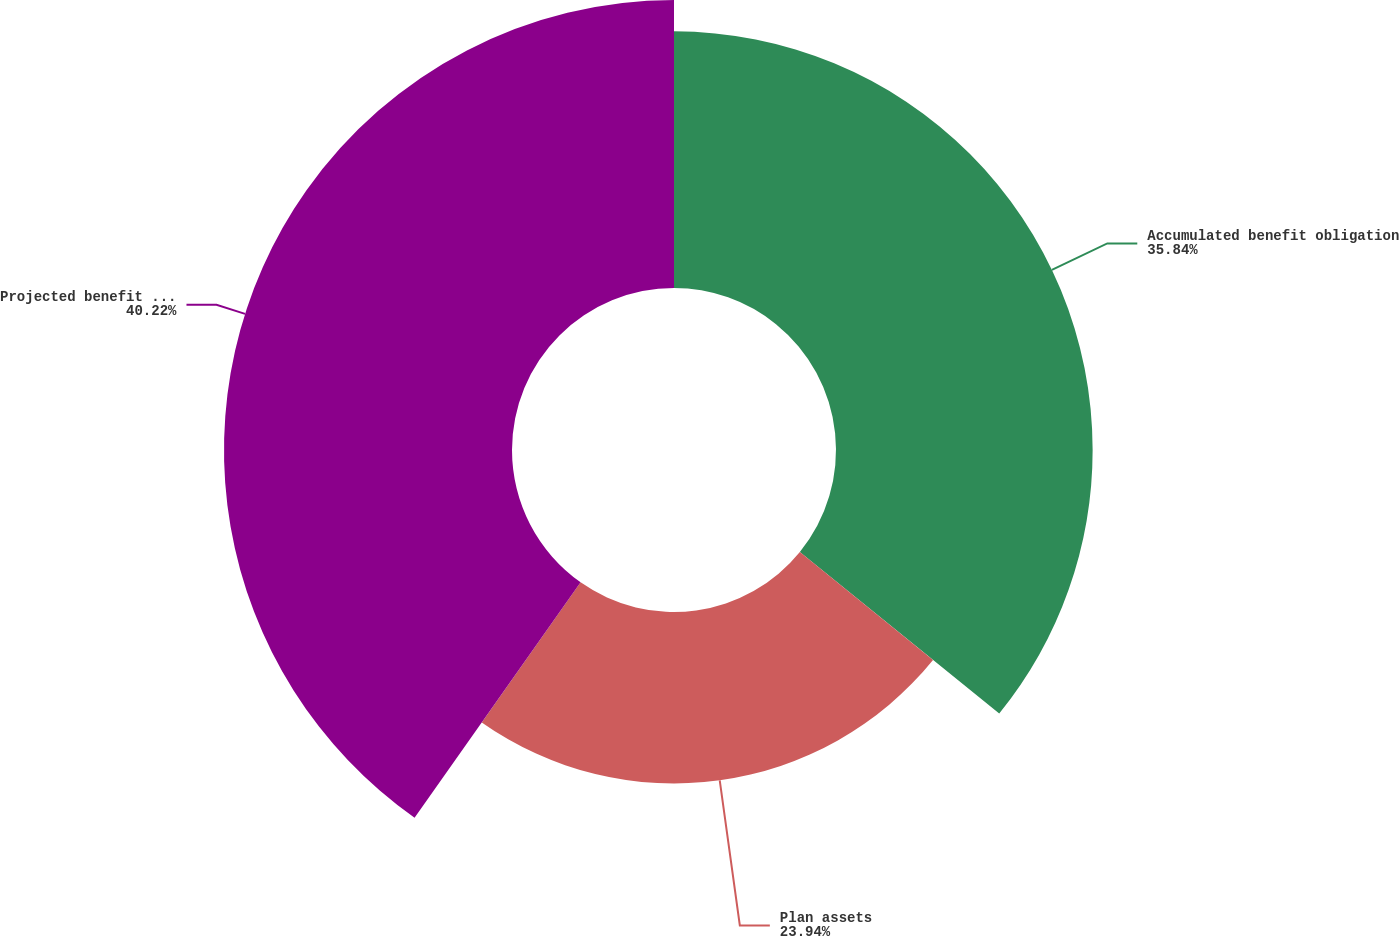Convert chart to OTSL. <chart><loc_0><loc_0><loc_500><loc_500><pie_chart><fcel>Accumulated benefit obligation<fcel>Plan assets<fcel>Projected benefit obligation<nl><fcel>35.84%<fcel>23.94%<fcel>40.22%<nl></chart> 